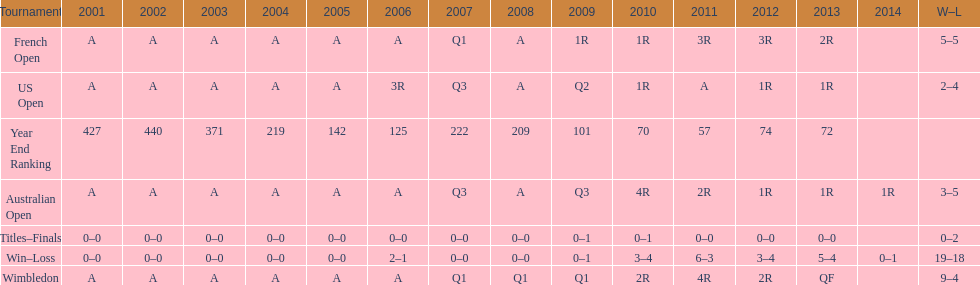What was this players average ranking between 2001 and 2006? 287. 